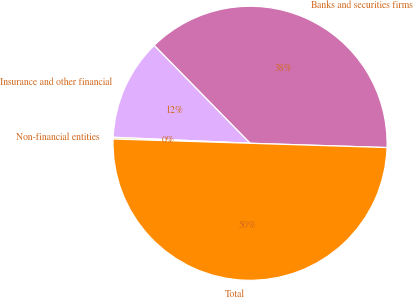Convert chart to OTSL. <chart><loc_0><loc_0><loc_500><loc_500><pie_chart><fcel>Banks and securities firms<fcel>Insurance and other financial<fcel>Non-financial entities<fcel>Total<nl><fcel>37.84%<fcel>11.96%<fcel>0.2%<fcel>50.0%<nl></chart> 